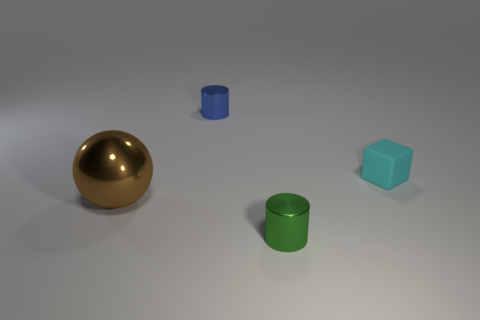Add 1 tiny green shiny cylinders. How many objects exist? 5 Subtract all spheres. How many objects are left? 3 Subtract 1 brown spheres. How many objects are left? 3 Subtract all metal cylinders. Subtract all large metal objects. How many objects are left? 1 Add 2 metallic objects. How many metallic objects are left? 5 Add 2 brown cubes. How many brown cubes exist? 2 